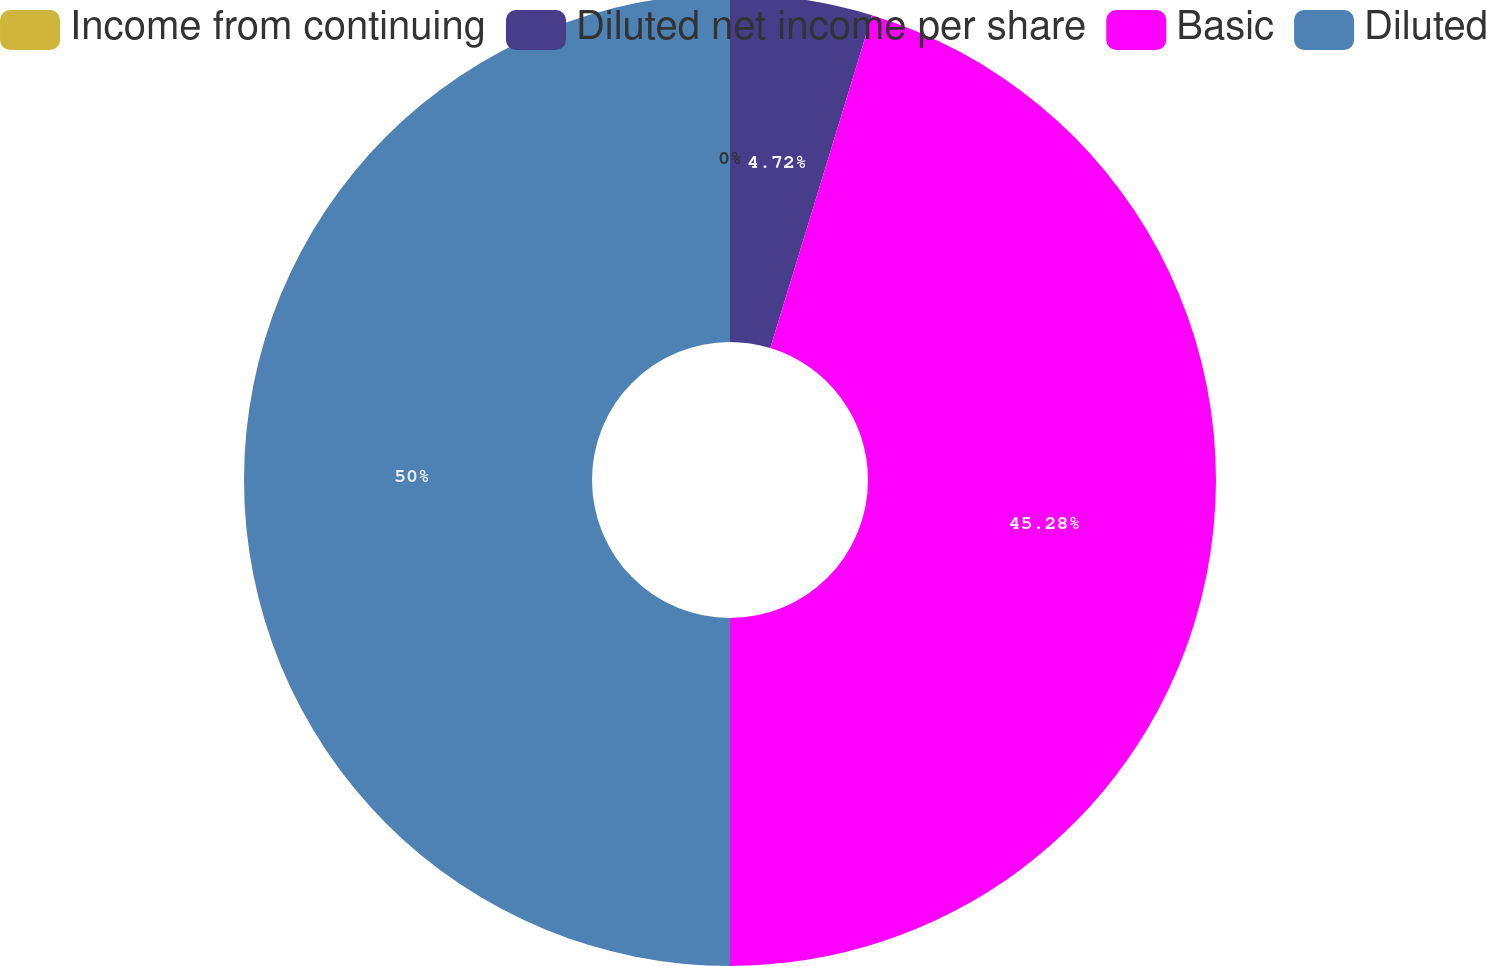<chart> <loc_0><loc_0><loc_500><loc_500><pie_chart><fcel>Income from continuing<fcel>Diluted net income per share<fcel>Basic<fcel>Diluted<nl><fcel>0.0%<fcel>4.72%<fcel>45.28%<fcel>50.0%<nl></chart> 